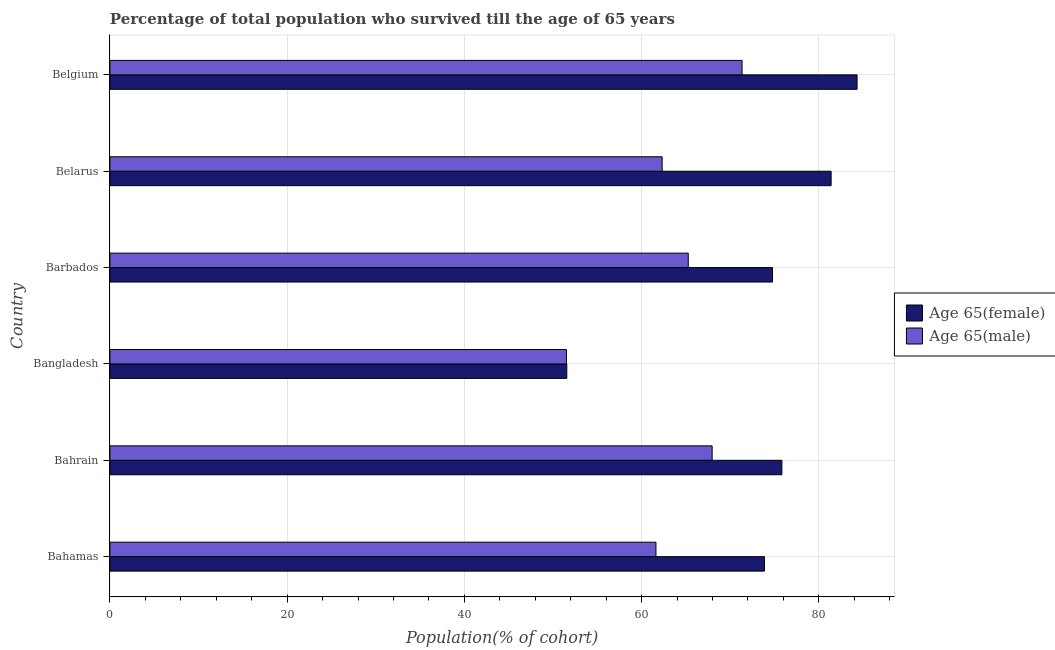How many groups of bars are there?
Provide a succinct answer. 6. Are the number of bars on each tick of the Y-axis equal?
Offer a terse response. Yes. How many bars are there on the 2nd tick from the top?
Make the answer very short. 2. How many bars are there on the 5th tick from the bottom?
Offer a very short reply. 2. What is the percentage of male population who survived till age of 65 in Bahamas?
Provide a succinct answer. 61.63. Across all countries, what is the maximum percentage of male population who survived till age of 65?
Provide a short and direct response. 71.34. Across all countries, what is the minimum percentage of female population who survived till age of 65?
Provide a short and direct response. 51.56. In which country was the percentage of female population who survived till age of 65 minimum?
Your answer should be very brief. Bangladesh. What is the total percentage of female population who survived till age of 65 in the graph?
Give a very brief answer. 441.77. What is the difference between the percentage of female population who survived till age of 65 in Bangladesh and that in Belgium?
Your answer should be compact. -32.76. What is the difference between the percentage of female population who survived till age of 65 in Bangladesh and the percentage of male population who survived till age of 65 in Bahrain?
Offer a terse response. -16.4. What is the average percentage of female population who survived till age of 65 per country?
Offer a terse response. 73.63. What is the difference between the percentage of female population who survived till age of 65 and percentage of male population who survived till age of 65 in Bahrain?
Make the answer very short. 7.87. What is the ratio of the percentage of male population who survived till age of 65 in Bahamas to that in Barbados?
Your answer should be very brief. 0.94. What is the difference between the highest and the second highest percentage of male population who survived till age of 65?
Ensure brevity in your answer.  3.38. What is the difference between the highest and the lowest percentage of male population who survived till age of 65?
Offer a terse response. 19.82. Is the sum of the percentage of male population who survived till age of 65 in Bahamas and Belgium greater than the maximum percentage of female population who survived till age of 65 across all countries?
Provide a succinct answer. Yes. What does the 1st bar from the top in Belgium represents?
Offer a very short reply. Age 65(male). What does the 2nd bar from the bottom in Barbados represents?
Provide a succinct answer. Age 65(male). How many legend labels are there?
Your answer should be very brief. 2. How are the legend labels stacked?
Offer a very short reply. Vertical. What is the title of the graph?
Keep it short and to the point. Percentage of total population who survived till the age of 65 years. What is the label or title of the X-axis?
Make the answer very short. Population(% of cohort). What is the Population(% of cohort) of Age 65(female) in Bahamas?
Give a very brief answer. 73.87. What is the Population(% of cohort) of Age 65(male) in Bahamas?
Offer a very short reply. 61.63. What is the Population(% of cohort) of Age 65(female) in Bahrain?
Offer a very short reply. 75.84. What is the Population(% of cohort) of Age 65(male) in Bahrain?
Offer a terse response. 67.97. What is the Population(% of cohort) in Age 65(female) in Bangladesh?
Offer a very short reply. 51.56. What is the Population(% of cohort) in Age 65(male) in Bangladesh?
Ensure brevity in your answer.  51.52. What is the Population(% of cohort) of Age 65(female) in Barbados?
Provide a succinct answer. 74.78. What is the Population(% of cohort) in Age 65(male) in Barbados?
Make the answer very short. 65.27. What is the Population(% of cohort) of Age 65(female) in Belarus?
Offer a very short reply. 81.39. What is the Population(% of cohort) in Age 65(male) in Belarus?
Give a very brief answer. 62.33. What is the Population(% of cohort) in Age 65(female) in Belgium?
Give a very brief answer. 84.32. What is the Population(% of cohort) in Age 65(male) in Belgium?
Keep it short and to the point. 71.34. Across all countries, what is the maximum Population(% of cohort) in Age 65(female)?
Provide a succinct answer. 84.32. Across all countries, what is the maximum Population(% of cohort) of Age 65(male)?
Provide a short and direct response. 71.34. Across all countries, what is the minimum Population(% of cohort) of Age 65(female)?
Ensure brevity in your answer.  51.56. Across all countries, what is the minimum Population(% of cohort) of Age 65(male)?
Provide a short and direct response. 51.52. What is the total Population(% of cohort) of Age 65(female) in the graph?
Offer a very short reply. 441.77. What is the total Population(% of cohort) in Age 65(male) in the graph?
Make the answer very short. 380.05. What is the difference between the Population(% of cohort) of Age 65(female) in Bahamas and that in Bahrain?
Offer a very short reply. -1.96. What is the difference between the Population(% of cohort) of Age 65(male) in Bahamas and that in Bahrain?
Provide a succinct answer. -6.34. What is the difference between the Population(% of cohort) in Age 65(female) in Bahamas and that in Bangladesh?
Your response must be concise. 22.31. What is the difference between the Population(% of cohort) of Age 65(male) in Bahamas and that in Bangladesh?
Keep it short and to the point. 10.1. What is the difference between the Population(% of cohort) of Age 65(female) in Bahamas and that in Barbados?
Provide a short and direct response. -0.91. What is the difference between the Population(% of cohort) of Age 65(male) in Bahamas and that in Barbados?
Provide a short and direct response. -3.65. What is the difference between the Population(% of cohort) of Age 65(female) in Bahamas and that in Belarus?
Offer a very short reply. -7.52. What is the difference between the Population(% of cohort) of Age 65(male) in Bahamas and that in Belarus?
Provide a succinct answer. -0.7. What is the difference between the Population(% of cohort) in Age 65(female) in Bahamas and that in Belgium?
Offer a terse response. -10.45. What is the difference between the Population(% of cohort) in Age 65(male) in Bahamas and that in Belgium?
Keep it short and to the point. -9.72. What is the difference between the Population(% of cohort) of Age 65(female) in Bahrain and that in Bangladesh?
Provide a succinct answer. 24.27. What is the difference between the Population(% of cohort) of Age 65(male) in Bahrain and that in Bangladesh?
Your response must be concise. 16.44. What is the difference between the Population(% of cohort) of Age 65(female) in Bahrain and that in Barbados?
Provide a succinct answer. 1.06. What is the difference between the Population(% of cohort) in Age 65(male) in Bahrain and that in Barbados?
Provide a succinct answer. 2.69. What is the difference between the Population(% of cohort) in Age 65(female) in Bahrain and that in Belarus?
Ensure brevity in your answer.  -5.56. What is the difference between the Population(% of cohort) of Age 65(male) in Bahrain and that in Belarus?
Your answer should be very brief. 5.64. What is the difference between the Population(% of cohort) of Age 65(female) in Bahrain and that in Belgium?
Provide a short and direct response. -8.48. What is the difference between the Population(% of cohort) in Age 65(male) in Bahrain and that in Belgium?
Offer a terse response. -3.38. What is the difference between the Population(% of cohort) of Age 65(female) in Bangladesh and that in Barbados?
Provide a succinct answer. -23.22. What is the difference between the Population(% of cohort) in Age 65(male) in Bangladesh and that in Barbados?
Keep it short and to the point. -13.75. What is the difference between the Population(% of cohort) in Age 65(female) in Bangladesh and that in Belarus?
Your answer should be very brief. -29.83. What is the difference between the Population(% of cohort) in Age 65(male) in Bangladesh and that in Belarus?
Your answer should be compact. -10.8. What is the difference between the Population(% of cohort) in Age 65(female) in Bangladesh and that in Belgium?
Your answer should be compact. -32.76. What is the difference between the Population(% of cohort) in Age 65(male) in Bangladesh and that in Belgium?
Your answer should be very brief. -19.82. What is the difference between the Population(% of cohort) in Age 65(female) in Barbados and that in Belarus?
Keep it short and to the point. -6.61. What is the difference between the Population(% of cohort) of Age 65(male) in Barbados and that in Belarus?
Offer a very short reply. 2.95. What is the difference between the Population(% of cohort) in Age 65(female) in Barbados and that in Belgium?
Give a very brief answer. -9.54. What is the difference between the Population(% of cohort) in Age 65(male) in Barbados and that in Belgium?
Your answer should be very brief. -6.07. What is the difference between the Population(% of cohort) in Age 65(female) in Belarus and that in Belgium?
Your response must be concise. -2.93. What is the difference between the Population(% of cohort) of Age 65(male) in Belarus and that in Belgium?
Keep it short and to the point. -9.02. What is the difference between the Population(% of cohort) in Age 65(female) in Bahamas and the Population(% of cohort) in Age 65(male) in Bahrain?
Give a very brief answer. 5.91. What is the difference between the Population(% of cohort) in Age 65(female) in Bahamas and the Population(% of cohort) in Age 65(male) in Bangladesh?
Your answer should be very brief. 22.35. What is the difference between the Population(% of cohort) in Age 65(female) in Bahamas and the Population(% of cohort) in Age 65(male) in Barbados?
Your answer should be very brief. 8.6. What is the difference between the Population(% of cohort) of Age 65(female) in Bahamas and the Population(% of cohort) of Age 65(male) in Belarus?
Offer a very short reply. 11.55. What is the difference between the Population(% of cohort) in Age 65(female) in Bahamas and the Population(% of cohort) in Age 65(male) in Belgium?
Provide a short and direct response. 2.53. What is the difference between the Population(% of cohort) of Age 65(female) in Bahrain and the Population(% of cohort) of Age 65(male) in Bangladesh?
Your answer should be very brief. 24.32. What is the difference between the Population(% of cohort) in Age 65(female) in Bahrain and the Population(% of cohort) in Age 65(male) in Barbados?
Make the answer very short. 10.57. What is the difference between the Population(% of cohort) of Age 65(female) in Bahrain and the Population(% of cohort) of Age 65(male) in Belarus?
Ensure brevity in your answer.  13.51. What is the difference between the Population(% of cohort) of Age 65(female) in Bahrain and the Population(% of cohort) of Age 65(male) in Belgium?
Offer a very short reply. 4.49. What is the difference between the Population(% of cohort) in Age 65(female) in Bangladesh and the Population(% of cohort) in Age 65(male) in Barbados?
Your answer should be very brief. -13.71. What is the difference between the Population(% of cohort) in Age 65(female) in Bangladesh and the Population(% of cohort) in Age 65(male) in Belarus?
Your response must be concise. -10.76. What is the difference between the Population(% of cohort) of Age 65(female) in Bangladesh and the Population(% of cohort) of Age 65(male) in Belgium?
Your response must be concise. -19.78. What is the difference between the Population(% of cohort) in Age 65(female) in Barbados and the Population(% of cohort) in Age 65(male) in Belarus?
Your response must be concise. 12.45. What is the difference between the Population(% of cohort) of Age 65(female) in Barbados and the Population(% of cohort) of Age 65(male) in Belgium?
Your response must be concise. 3.44. What is the difference between the Population(% of cohort) in Age 65(female) in Belarus and the Population(% of cohort) in Age 65(male) in Belgium?
Provide a short and direct response. 10.05. What is the average Population(% of cohort) of Age 65(female) per country?
Keep it short and to the point. 73.63. What is the average Population(% of cohort) of Age 65(male) per country?
Offer a terse response. 63.34. What is the difference between the Population(% of cohort) in Age 65(female) and Population(% of cohort) in Age 65(male) in Bahamas?
Provide a short and direct response. 12.25. What is the difference between the Population(% of cohort) in Age 65(female) and Population(% of cohort) in Age 65(male) in Bahrain?
Provide a succinct answer. 7.87. What is the difference between the Population(% of cohort) of Age 65(female) and Population(% of cohort) of Age 65(male) in Bangladesh?
Provide a short and direct response. 0.04. What is the difference between the Population(% of cohort) of Age 65(female) and Population(% of cohort) of Age 65(male) in Barbados?
Make the answer very short. 9.51. What is the difference between the Population(% of cohort) in Age 65(female) and Population(% of cohort) in Age 65(male) in Belarus?
Ensure brevity in your answer.  19.07. What is the difference between the Population(% of cohort) in Age 65(female) and Population(% of cohort) in Age 65(male) in Belgium?
Provide a succinct answer. 12.98. What is the ratio of the Population(% of cohort) of Age 65(female) in Bahamas to that in Bahrain?
Your answer should be very brief. 0.97. What is the ratio of the Population(% of cohort) in Age 65(male) in Bahamas to that in Bahrain?
Provide a succinct answer. 0.91. What is the ratio of the Population(% of cohort) in Age 65(female) in Bahamas to that in Bangladesh?
Keep it short and to the point. 1.43. What is the ratio of the Population(% of cohort) in Age 65(male) in Bahamas to that in Bangladesh?
Your answer should be very brief. 1.2. What is the ratio of the Population(% of cohort) of Age 65(female) in Bahamas to that in Barbados?
Ensure brevity in your answer.  0.99. What is the ratio of the Population(% of cohort) of Age 65(male) in Bahamas to that in Barbados?
Your answer should be compact. 0.94. What is the ratio of the Population(% of cohort) of Age 65(female) in Bahamas to that in Belarus?
Your response must be concise. 0.91. What is the ratio of the Population(% of cohort) in Age 65(female) in Bahamas to that in Belgium?
Your answer should be compact. 0.88. What is the ratio of the Population(% of cohort) in Age 65(male) in Bahamas to that in Belgium?
Your answer should be compact. 0.86. What is the ratio of the Population(% of cohort) of Age 65(female) in Bahrain to that in Bangladesh?
Make the answer very short. 1.47. What is the ratio of the Population(% of cohort) in Age 65(male) in Bahrain to that in Bangladesh?
Your answer should be very brief. 1.32. What is the ratio of the Population(% of cohort) of Age 65(female) in Bahrain to that in Barbados?
Keep it short and to the point. 1.01. What is the ratio of the Population(% of cohort) of Age 65(male) in Bahrain to that in Barbados?
Your response must be concise. 1.04. What is the ratio of the Population(% of cohort) of Age 65(female) in Bahrain to that in Belarus?
Provide a short and direct response. 0.93. What is the ratio of the Population(% of cohort) in Age 65(male) in Bahrain to that in Belarus?
Ensure brevity in your answer.  1.09. What is the ratio of the Population(% of cohort) of Age 65(female) in Bahrain to that in Belgium?
Your answer should be compact. 0.9. What is the ratio of the Population(% of cohort) of Age 65(male) in Bahrain to that in Belgium?
Your answer should be compact. 0.95. What is the ratio of the Population(% of cohort) of Age 65(female) in Bangladesh to that in Barbados?
Your answer should be very brief. 0.69. What is the ratio of the Population(% of cohort) of Age 65(male) in Bangladesh to that in Barbados?
Offer a terse response. 0.79. What is the ratio of the Population(% of cohort) in Age 65(female) in Bangladesh to that in Belarus?
Provide a short and direct response. 0.63. What is the ratio of the Population(% of cohort) in Age 65(male) in Bangladesh to that in Belarus?
Provide a succinct answer. 0.83. What is the ratio of the Population(% of cohort) of Age 65(female) in Bangladesh to that in Belgium?
Give a very brief answer. 0.61. What is the ratio of the Population(% of cohort) in Age 65(male) in Bangladesh to that in Belgium?
Give a very brief answer. 0.72. What is the ratio of the Population(% of cohort) of Age 65(female) in Barbados to that in Belarus?
Give a very brief answer. 0.92. What is the ratio of the Population(% of cohort) in Age 65(male) in Barbados to that in Belarus?
Provide a short and direct response. 1.05. What is the ratio of the Population(% of cohort) in Age 65(female) in Barbados to that in Belgium?
Offer a very short reply. 0.89. What is the ratio of the Population(% of cohort) in Age 65(male) in Barbados to that in Belgium?
Give a very brief answer. 0.91. What is the ratio of the Population(% of cohort) of Age 65(female) in Belarus to that in Belgium?
Your answer should be compact. 0.97. What is the ratio of the Population(% of cohort) in Age 65(male) in Belarus to that in Belgium?
Provide a succinct answer. 0.87. What is the difference between the highest and the second highest Population(% of cohort) in Age 65(female)?
Ensure brevity in your answer.  2.93. What is the difference between the highest and the second highest Population(% of cohort) of Age 65(male)?
Provide a short and direct response. 3.38. What is the difference between the highest and the lowest Population(% of cohort) in Age 65(female)?
Offer a very short reply. 32.76. What is the difference between the highest and the lowest Population(% of cohort) of Age 65(male)?
Offer a terse response. 19.82. 